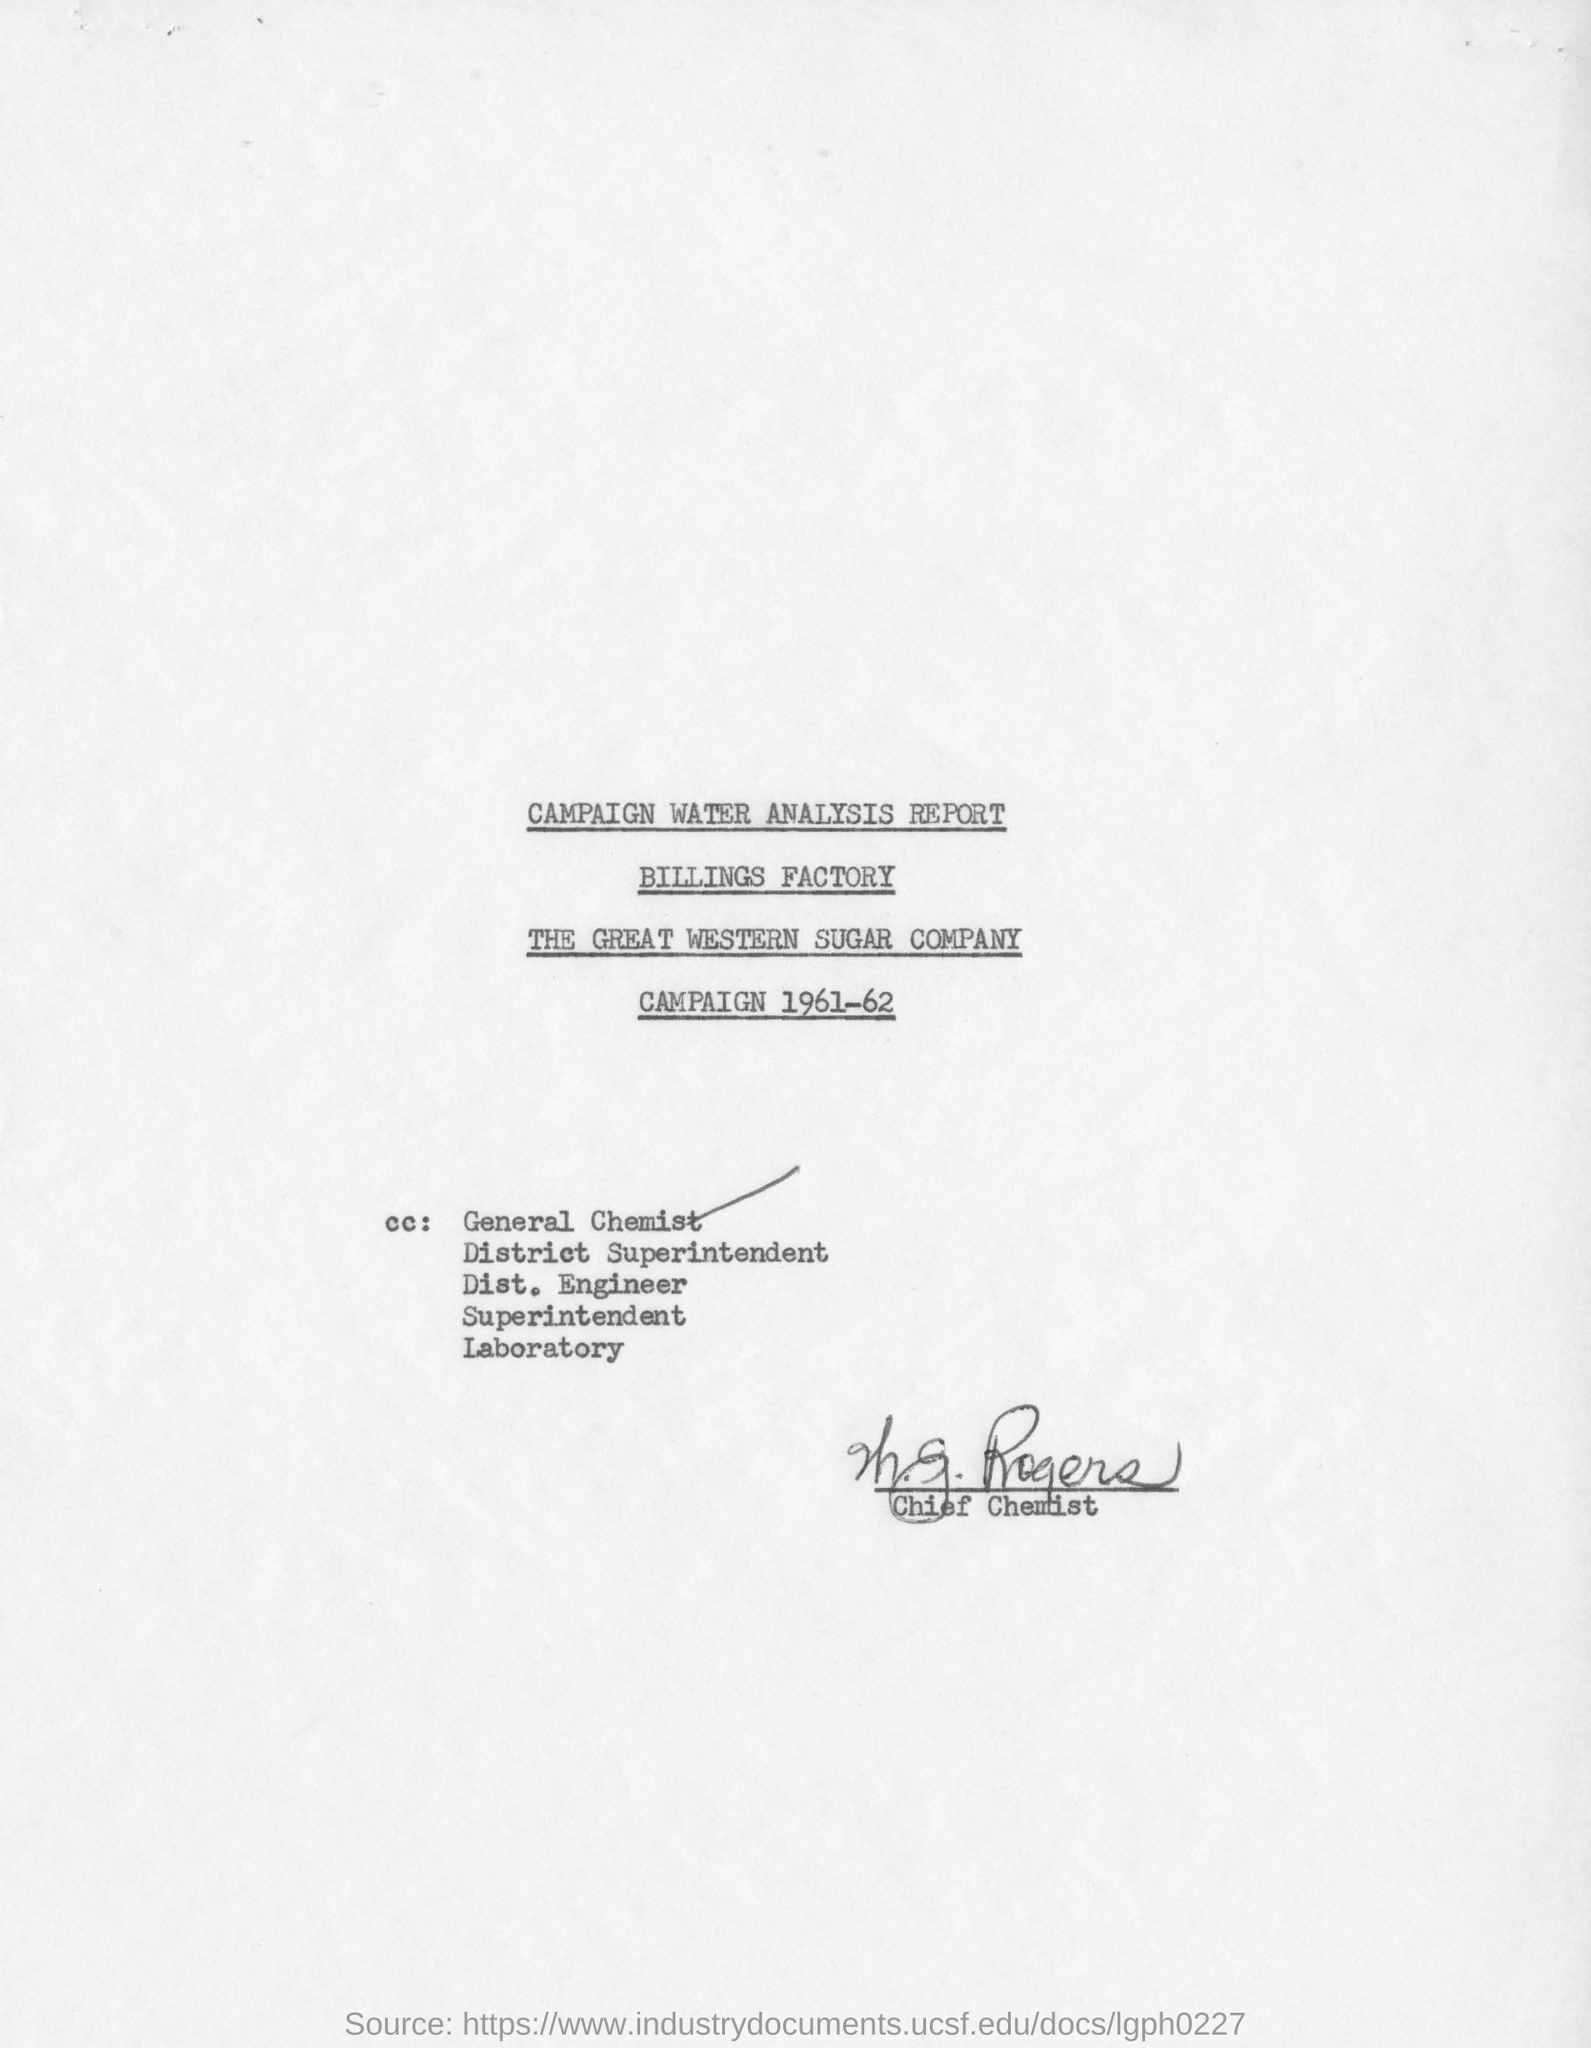Outline some significant characteristics in this image. This report is the Campaign Water Analysis Report. The specified company, THE GREAT WESTERN SUGAR COMPANY, is mentioned on this page. The document was signed by the chief chemist. 